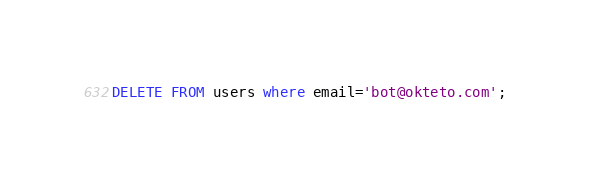<code> <loc_0><loc_0><loc_500><loc_500><_SQL_>DELETE FROM users where email='bot@okteto.com';</code> 